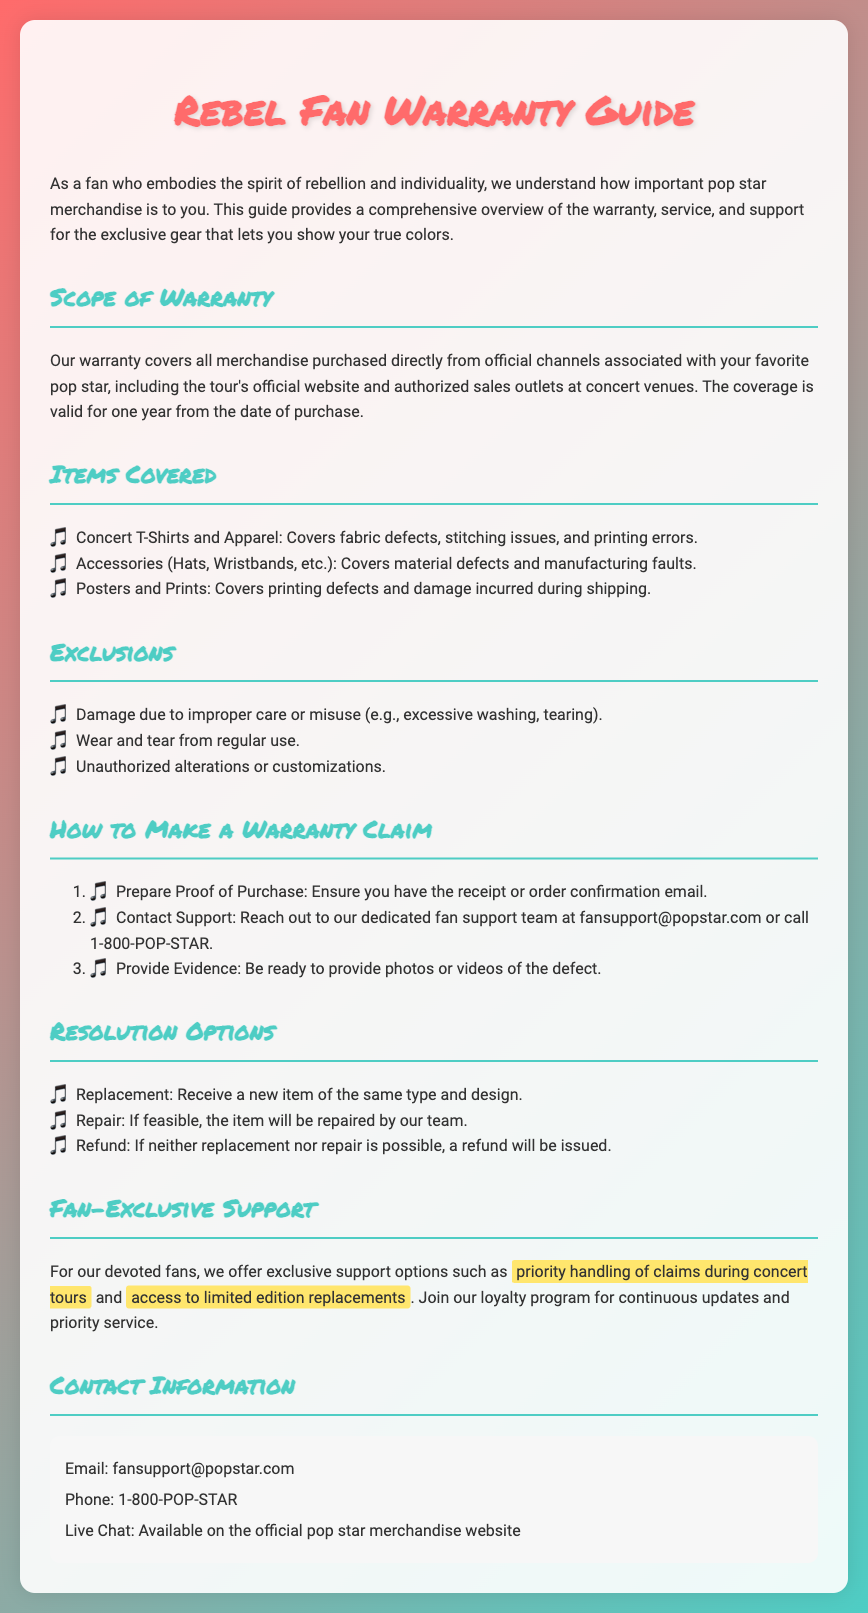What is the duration of the warranty? The warranty is valid for one year from the date of purchase.
Answer: One year What items are covered under the warranty? The covered items include Concert T-Shirts and Apparel, Accessories, and Posters and Prints.
Answer: T-Shirts, Accessories, Posters Who do I contact for support? The document provides contact information, including an email and phone number.
Answer: fansupport@popstar.com What is the first step to make a warranty claim? The first step is to prepare Proof of Purchase, which is the receipt or order confirmation email.
Answer: Proof of Purchase What is one exclusion under the warranty? The exclusions list includes several conditions; one example is damage due to improper care or misuse.
Answer: Improper care What resolution options are available for a warranty claim? The resolution options include Replacement, Repair, and Refund.
Answer: Replacement, Repair, Refund What special support does the warranty offer for fans? The document mentions providing priority handling of claims during concert tours as a special fan support option.
Answer: Priority handling How can I reach live support? The document states that live chat is available on the official pop star merchandise website for direct contact.
Answer: Live Chat What type of merchandise does the warranty cover? The warranty covers merchandise purchased directly from official channels associated with the pop star.
Answer: Merchandise from official channels 